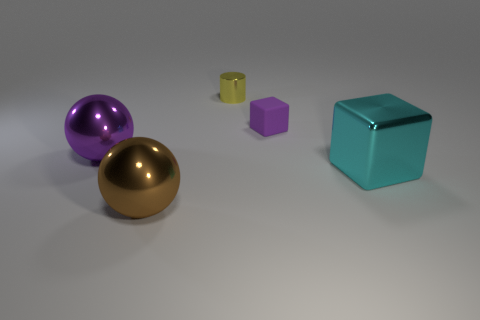Are there any other things that are the same material as the small purple thing?
Make the answer very short. No. How many other objects are the same material as the cyan thing?
Ensure brevity in your answer.  3. Do the big thing right of the yellow cylinder and the ball behind the brown sphere have the same material?
Make the answer very short. Yes. What shape is the big purple thing that is the same material as the cyan block?
Ensure brevity in your answer.  Sphere. Is there anything else of the same color as the large block?
Provide a succinct answer. No. How many yellow shiny things are there?
Your answer should be compact. 1. What shape is the shiny object that is to the right of the big brown metallic sphere and left of the large metallic cube?
Make the answer very short. Cylinder. The large object on the left side of the large object that is in front of the block in front of the tiny rubber object is what shape?
Keep it short and to the point. Sphere. The thing that is both right of the small yellow cylinder and behind the big purple thing is made of what material?
Keep it short and to the point. Rubber. How many objects have the same size as the cylinder?
Your answer should be very brief. 1. 